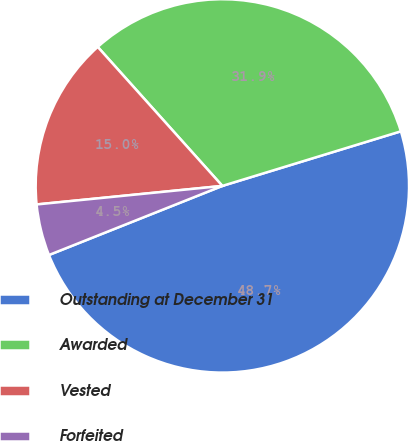Convert chart. <chart><loc_0><loc_0><loc_500><loc_500><pie_chart><fcel>Outstanding at December 31<fcel>Awarded<fcel>Vested<fcel>Forfeited<nl><fcel>48.69%<fcel>31.91%<fcel>14.95%<fcel>4.45%<nl></chart> 